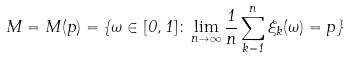<formula> <loc_0><loc_0><loc_500><loc_500>M = M ( p ) = \{ \omega \in [ 0 , 1 ] \colon \lim _ { n \to \infty } \frac { 1 } { n } \sum _ { k = 1 } ^ { n } \xi _ { k } ( \omega ) = p \}</formula> 